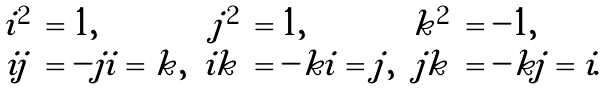<formula> <loc_0><loc_0><loc_500><loc_500>\begin{array} { r l r l r l } i ^ { 2 } & = 1 , & j ^ { 2 } & = 1 , & k ^ { 2 } & = - 1 , \\ i j & = - j i = k , & i k & = - k i = j , & j k & = - k j = i . \end{array}</formula> 